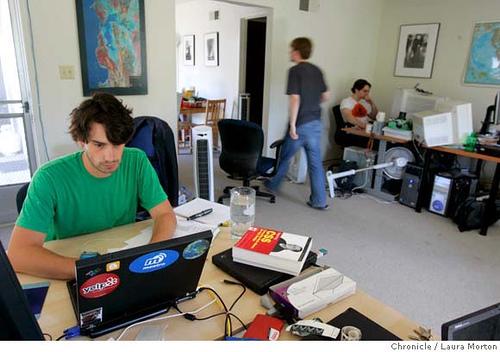What is the purpose of the fan under the desk?
Answer briefly. Storage. How many people are leaving the room?
Answer briefly. 1. How many people in the room?
Be succinct. 3. 